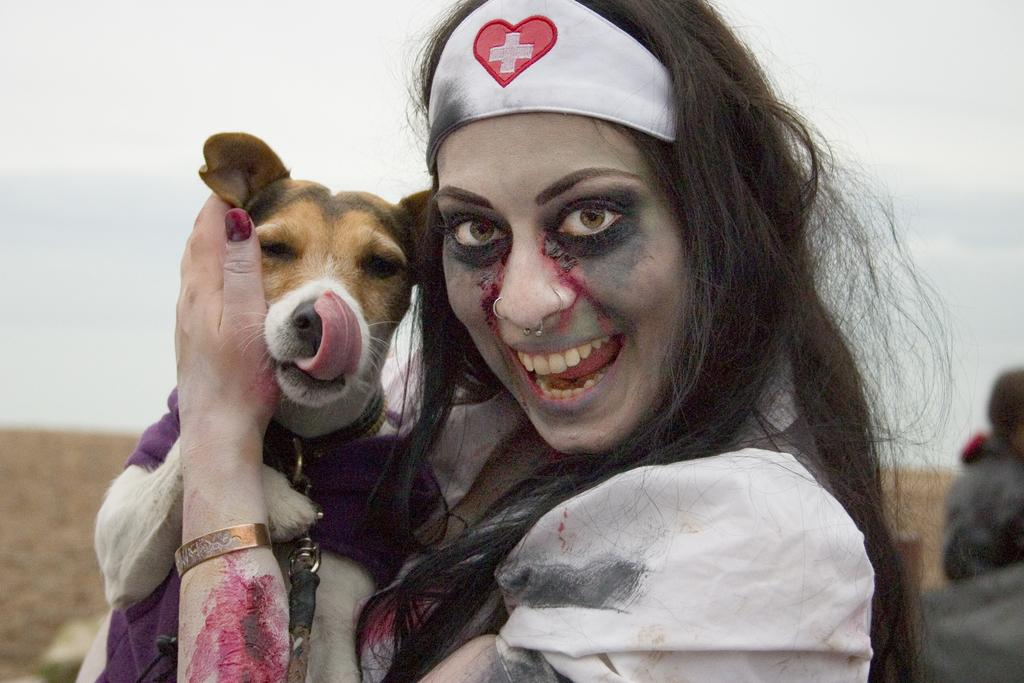What is the main subject of the image? The main subject of the image is a woman. What is the woman doing in the image? The woman is holding a dog in the image. What accessory is the woman wearing? The woman is wearing a headband in the image. What type of work is the dog doing in the image? The dog is not working in the image; it is being held by the woman. Can you see any wings on the woman in the image? There are no wings visible on the woman in the image. 